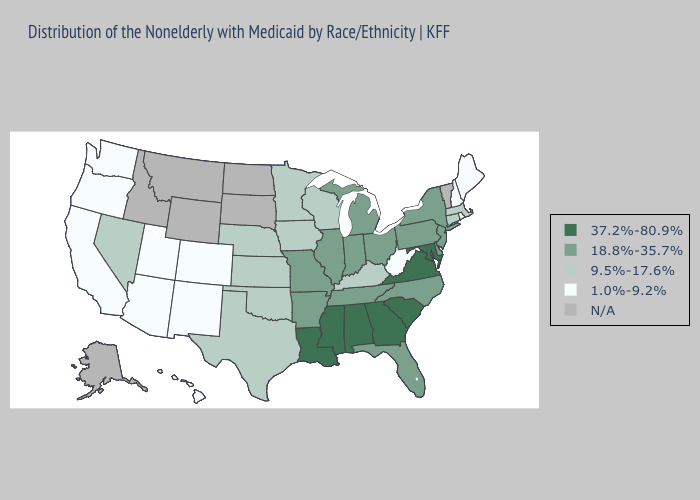Does the map have missing data?
Answer briefly. Yes. Does Nebraska have the lowest value in the MidWest?
Quick response, please. Yes. Does Colorado have the highest value in the USA?
Short answer required. No. Does Alabama have the highest value in the USA?
Short answer required. Yes. Among the states that border North Carolina , which have the highest value?
Concise answer only. Georgia, South Carolina, Virginia. What is the lowest value in states that border Washington?
Concise answer only. 1.0%-9.2%. How many symbols are there in the legend?
Concise answer only. 5. Does the first symbol in the legend represent the smallest category?
Write a very short answer. No. Which states have the lowest value in the Northeast?
Be succinct. Maine, New Hampshire, Rhode Island. Name the states that have a value in the range N/A?
Write a very short answer. Alaska, Idaho, Montana, North Dakota, South Dakota, Vermont, Wyoming. What is the value of Florida?
Write a very short answer. 18.8%-35.7%. What is the lowest value in the USA?
Short answer required. 1.0%-9.2%. What is the highest value in the USA?
Concise answer only. 37.2%-80.9%. Which states have the highest value in the USA?
Be succinct. Alabama, Georgia, Louisiana, Maryland, Mississippi, South Carolina, Virginia. 